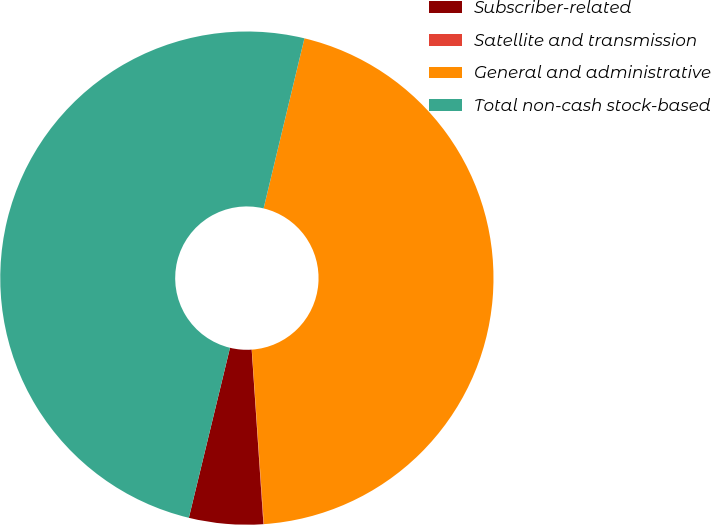Convert chart. <chart><loc_0><loc_0><loc_500><loc_500><pie_chart><fcel>Subscriber-related<fcel>Satellite and transmission<fcel>General and administrative<fcel>Total non-cash stock-based<nl><fcel>4.85%<fcel>0.03%<fcel>45.15%<fcel>49.97%<nl></chart> 